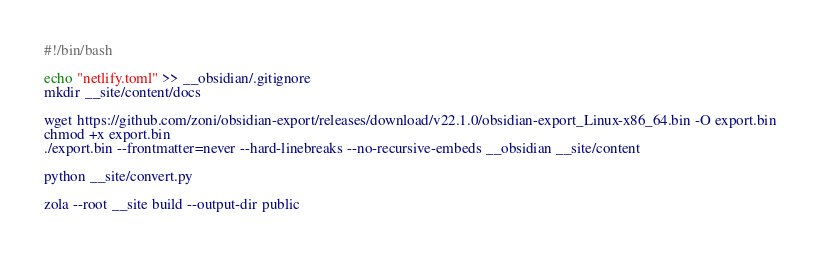<code> <loc_0><loc_0><loc_500><loc_500><_Bash_>#!/bin/bash

echo "netlify.toml" >> __obsidian/.gitignore
mkdir __site/content/docs

wget https://github.com/zoni/obsidian-export/releases/download/v22.1.0/obsidian-export_Linux-x86_64.bin -O export.bin
chmod +x export.bin
./export.bin --frontmatter=never --hard-linebreaks --no-recursive-embeds __obsidian __site/content

python __site/convert.py

zola --root __site build --output-dir public
</code> 